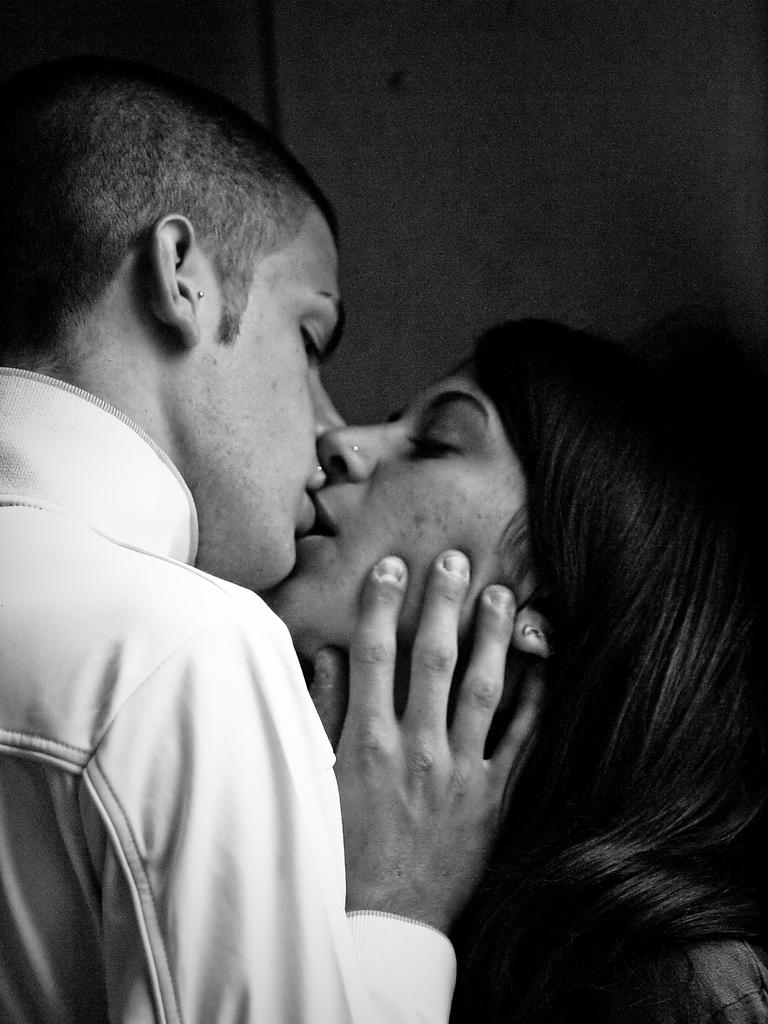What is the color scheme of the image? The image is black and white. What can be seen in the image involving two people? There is a couple in the image. What are the couple doing in the image? The couple is kissing. What is located at the top of the image? There is a well at the top of the image. What type of glove is the animal wearing in the image? There is no animal or glove present in the image. 